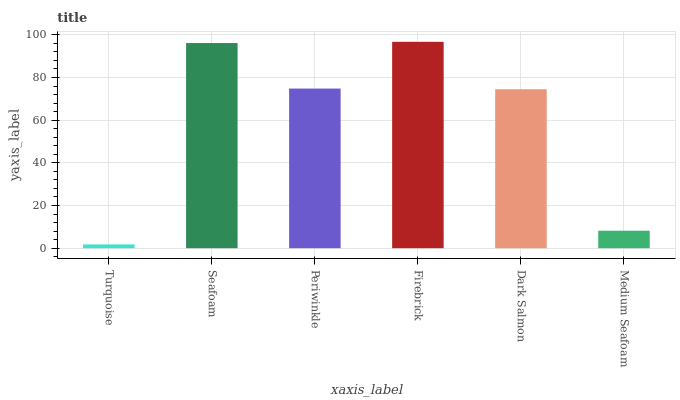Is Turquoise the minimum?
Answer yes or no. Yes. Is Firebrick the maximum?
Answer yes or no. Yes. Is Seafoam the minimum?
Answer yes or no. No. Is Seafoam the maximum?
Answer yes or no. No. Is Seafoam greater than Turquoise?
Answer yes or no. Yes. Is Turquoise less than Seafoam?
Answer yes or no. Yes. Is Turquoise greater than Seafoam?
Answer yes or no. No. Is Seafoam less than Turquoise?
Answer yes or no. No. Is Periwinkle the high median?
Answer yes or no. Yes. Is Dark Salmon the low median?
Answer yes or no. Yes. Is Medium Seafoam the high median?
Answer yes or no. No. Is Turquoise the low median?
Answer yes or no. No. 